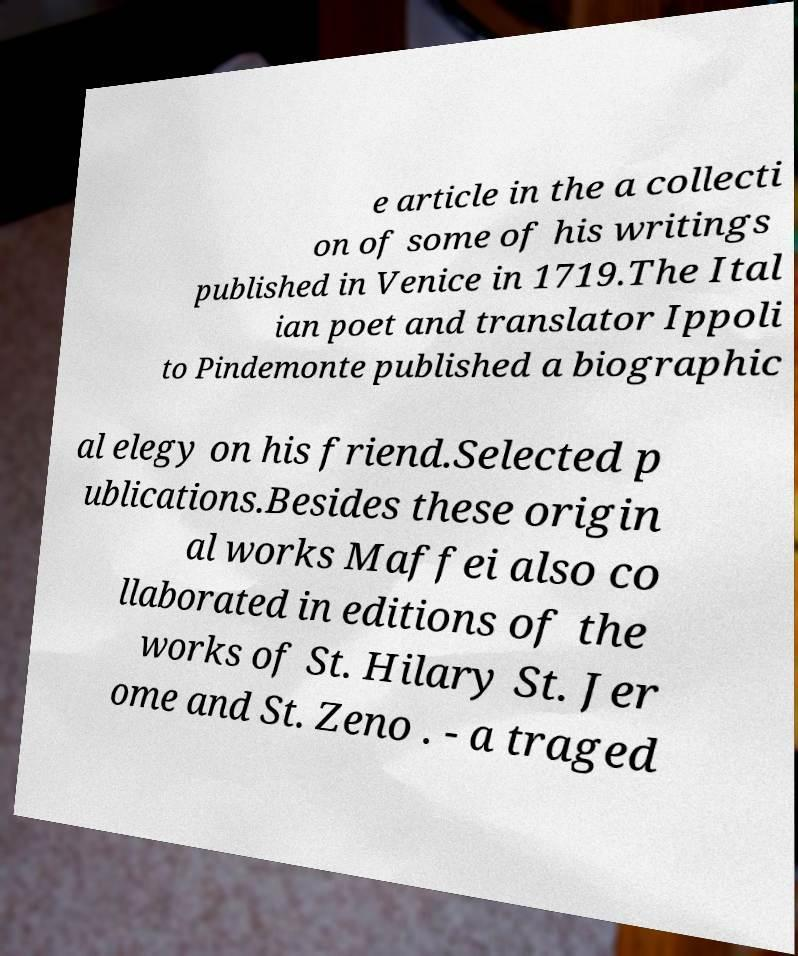I need the written content from this picture converted into text. Can you do that? e article in the a collecti on of some of his writings published in Venice in 1719.The Ital ian poet and translator Ippoli to Pindemonte published a biographic al elegy on his friend.Selected p ublications.Besides these origin al works Maffei also co llaborated in editions of the works of St. Hilary St. Jer ome and St. Zeno . - a traged 